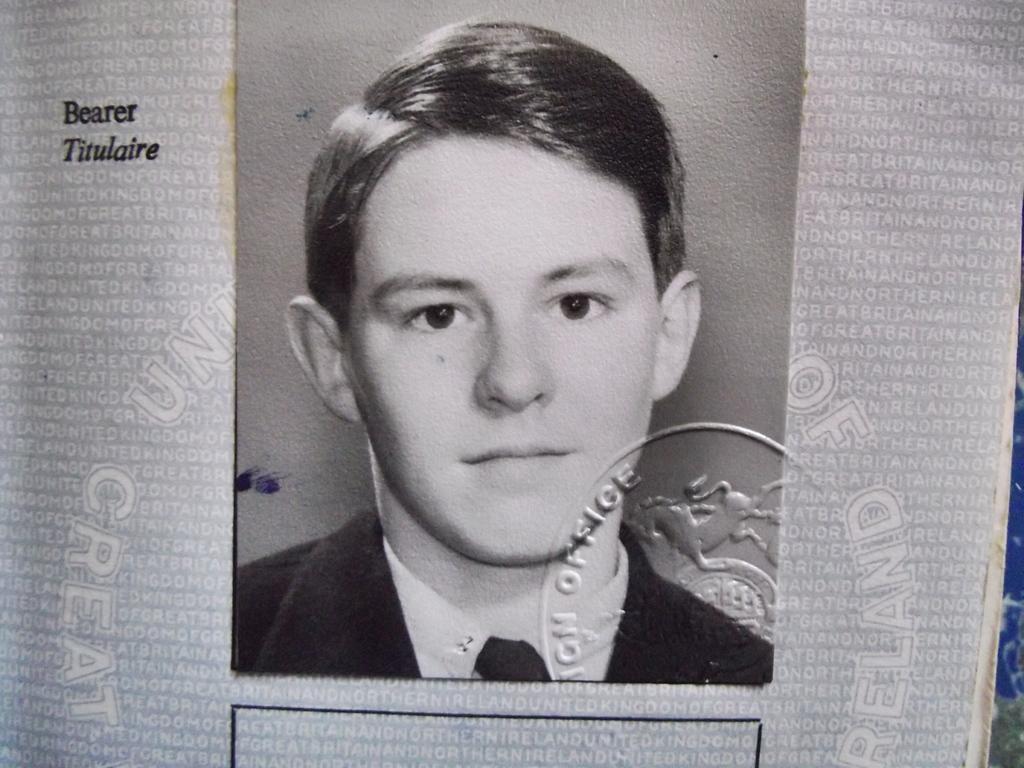In one or two sentences, can you explain what this image depicts? In this image we can see a black and white passport size photo is pasted on the paper. We can see watermarks on the paper and a stamp on the photograph. 